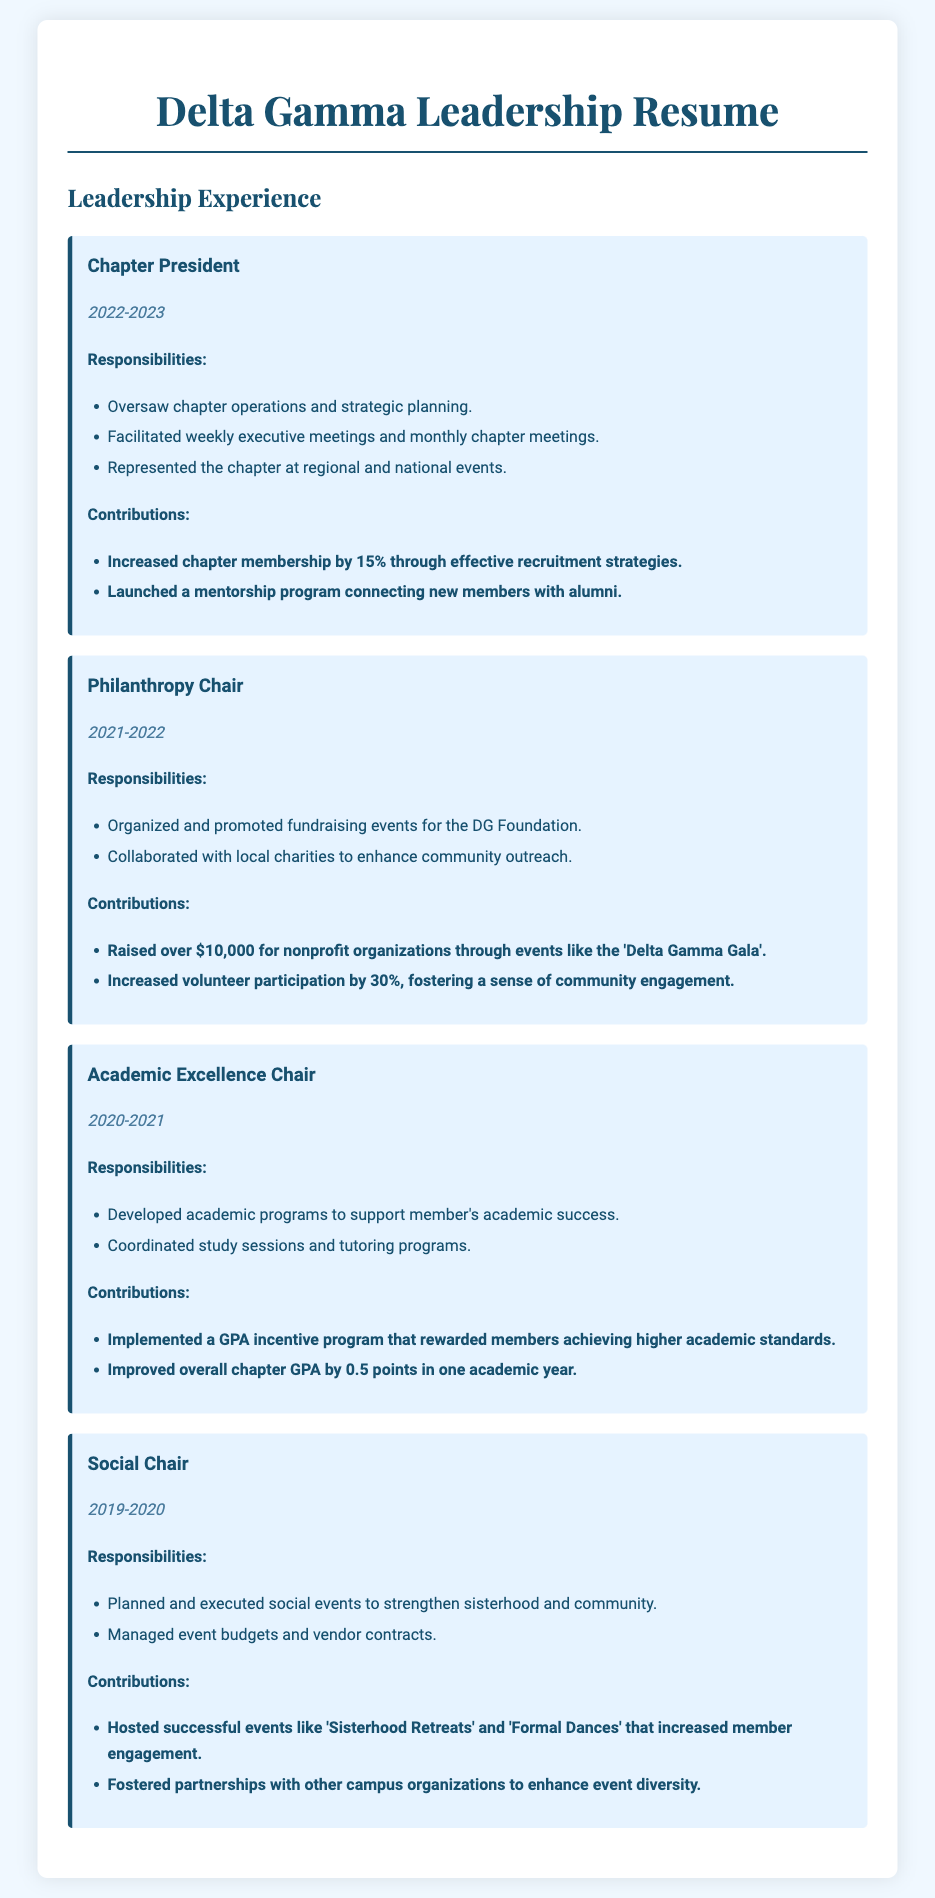What position did you hold in 2022-2023? The document states that the position held in 2022-2023 was Chapter President.
Answer: Chapter President How much money did the Philanthropy Chair raise? According to the document, the Philanthropy Chair raised over $10,000 for nonprofit organizations.
Answer: $10,000 What significant program did the Chapter President launch? The document indicates that the Chapter President launched a mentorship program connecting new members with alumni.
Answer: Mentorship program What was the percentage increase in volunteer participation under the Philanthropy Chair? Based on the document, the volunteer participation increased by 30% during the Philanthropy Chair's term.
Answer: 30% Which role contributed to an overall chapter GPA improvement? The document specifies that the Academic Excellence Chair contributed to the improvement of the overall chapter GPA by implementing a GPA incentive program.
Answer: Academic Excellence Chair What event did the Social Chair host to strengthen sisterhood? The document mentions that the Social Chair hosted successful Sisterhood Retreats to enhance community bonds.
Answer: Sisterhood Retreats How many main responsibilities are listed for the Academic Excellence Chair? The document outlines two main responsibilities for the Academic Excellence Chair.
Answer: Two In which year was the position of Social Chair held? The document states that the position of Social Chair was held in 2019-2020.
Answer: 2019-2020 